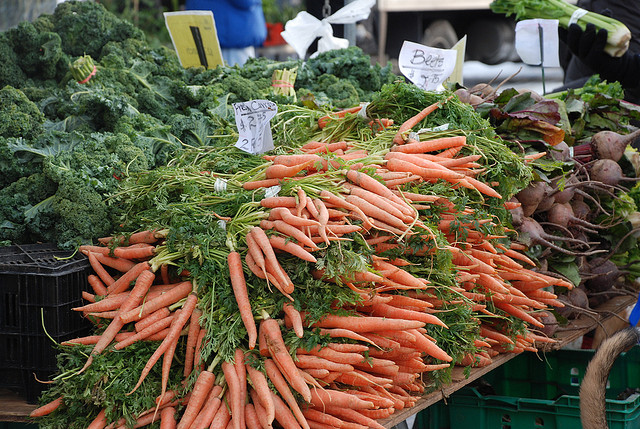Read and extract the text from this image. Best 2 